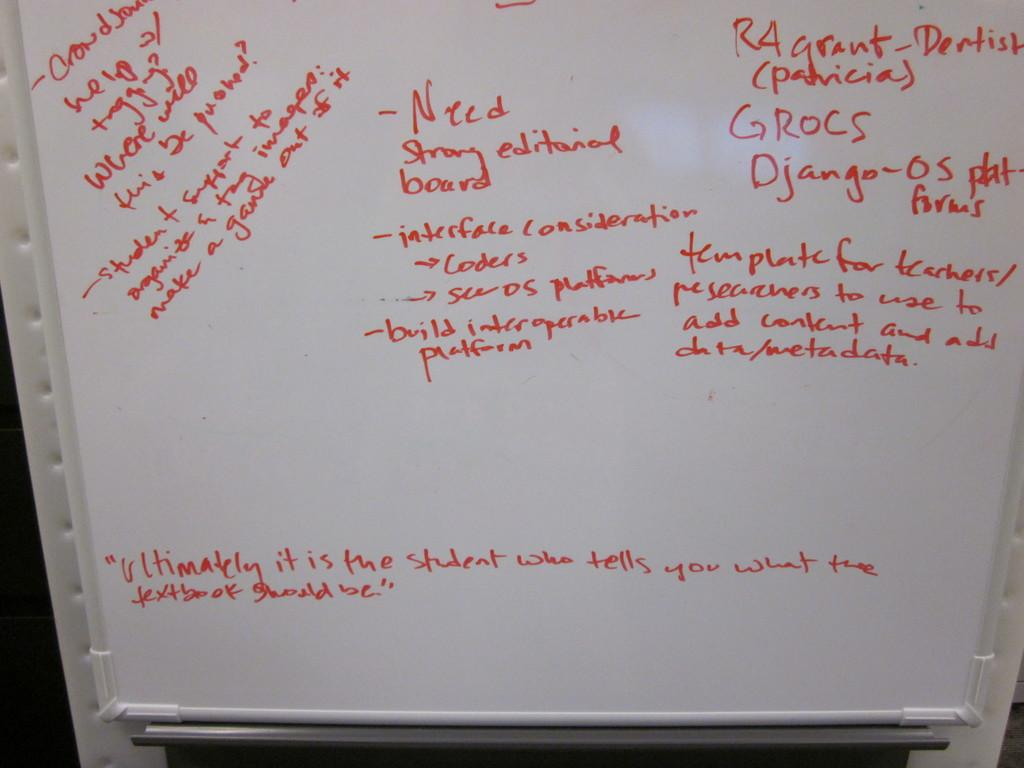<image>
Share a concise interpretation of the image provided. A whiteboard with quotes and notes about an editorial board. 